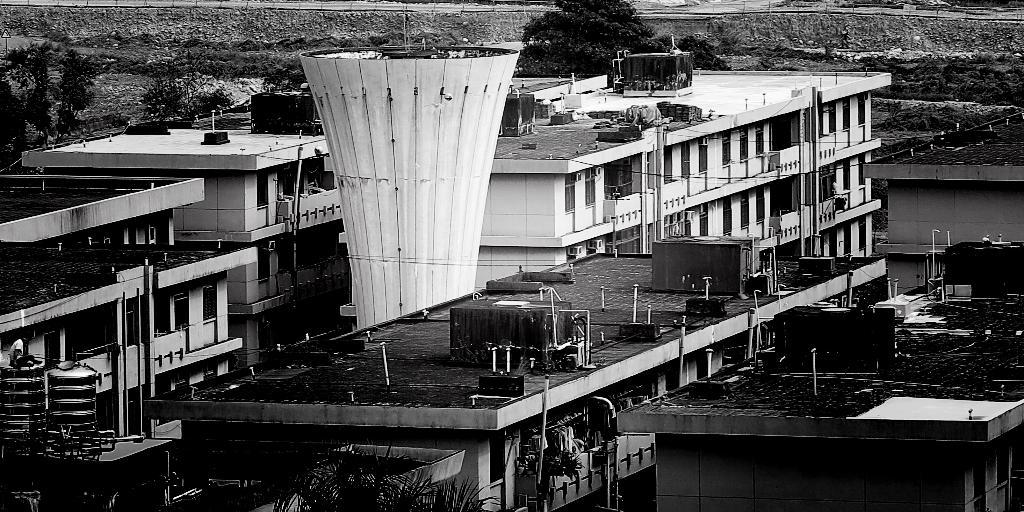What is the color scheme of the image? The image is black and white. What type of structures can be seen in the image? There are buildings and a tower in the image. What other natural elements are present in the image? There are trees in the image. Where is the sign board located in the image? The sign board is on the left side of the image. What is the rate of friction between the buildings in the image? There is no information about friction or any physical interactions between the buildings in the image, so it cannot be determined. 